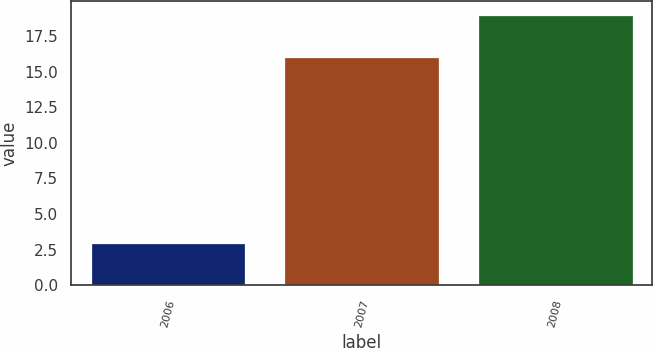Convert chart to OTSL. <chart><loc_0><loc_0><loc_500><loc_500><bar_chart><fcel>2006<fcel>2007<fcel>2008<nl><fcel>3<fcel>16<fcel>19<nl></chart> 